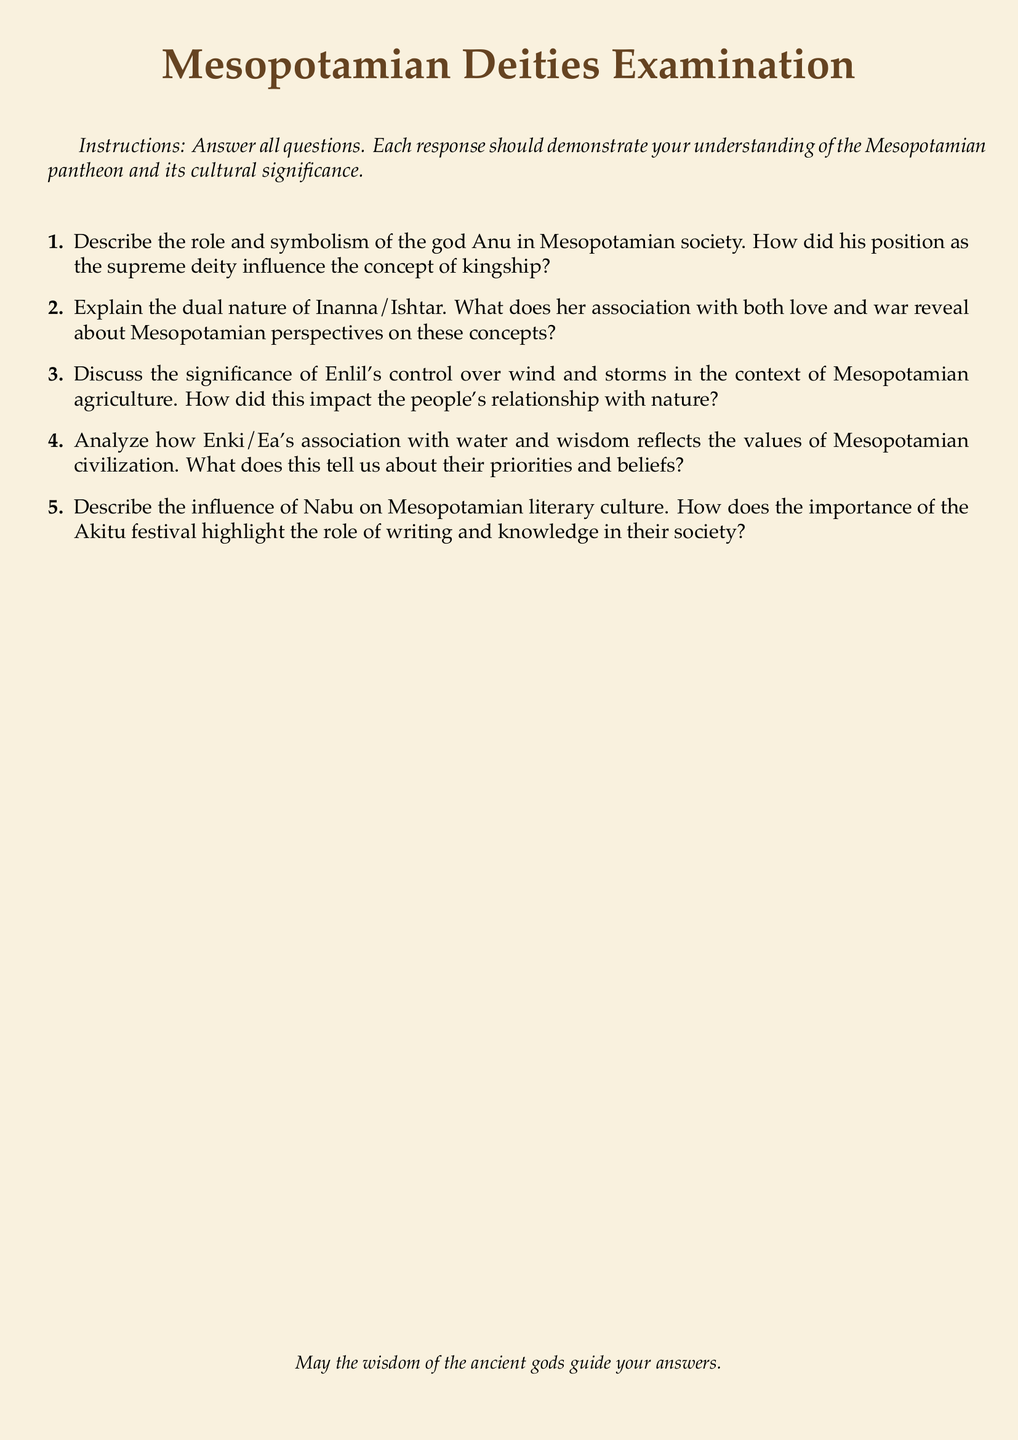What is the title of the document? The title of the document is prominently stated at the beginning, which is "Mesopotamian Deities Examination."
Answer: Mesopotamian Deities Examination How many sections are in the examination? The examination includes 5 sections, each asking about a different deity or concept.
Answer: 5 Which deity is associated with love and war? The deity associated with both love and war is mentioned in the second question of the examination.
Answer: Inanna/Ishtar What is Enki/Ea known for? Enki/Ea's association is described in terms of water and wisdom in question four.
Answer: Water and wisdom What festival highlights the role of writing in Mesopotamian society? The festival that emphasizes writing and knowledge in their culture is mentioned in the context of Nabu.
Answer: Akitu 